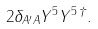<formula> <loc_0><loc_0><loc_500><loc_500>2 \delta _ { A ^ { \prime } A } Y ^ { 5 } Y ^ { 5 \, \dagger } .</formula> 